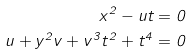<formula> <loc_0><loc_0><loc_500><loc_500>x ^ { 2 } - u t = 0 \\ u + y ^ { 2 } v + v ^ { 3 } t ^ { 2 } + t ^ { 4 } = 0</formula> 